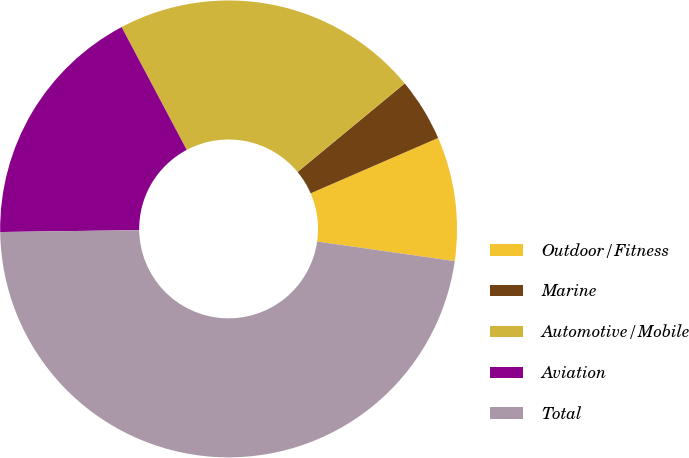Convert chart to OTSL. <chart><loc_0><loc_0><loc_500><loc_500><pie_chart><fcel>Outdoor/Fitness<fcel>Marine<fcel>Automotive/Mobile<fcel>Aviation<fcel>Total<nl><fcel>8.77%<fcel>4.47%<fcel>21.77%<fcel>17.46%<fcel>47.53%<nl></chart> 